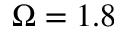<formula> <loc_0><loc_0><loc_500><loc_500>\Omega = 1 . 8</formula> 